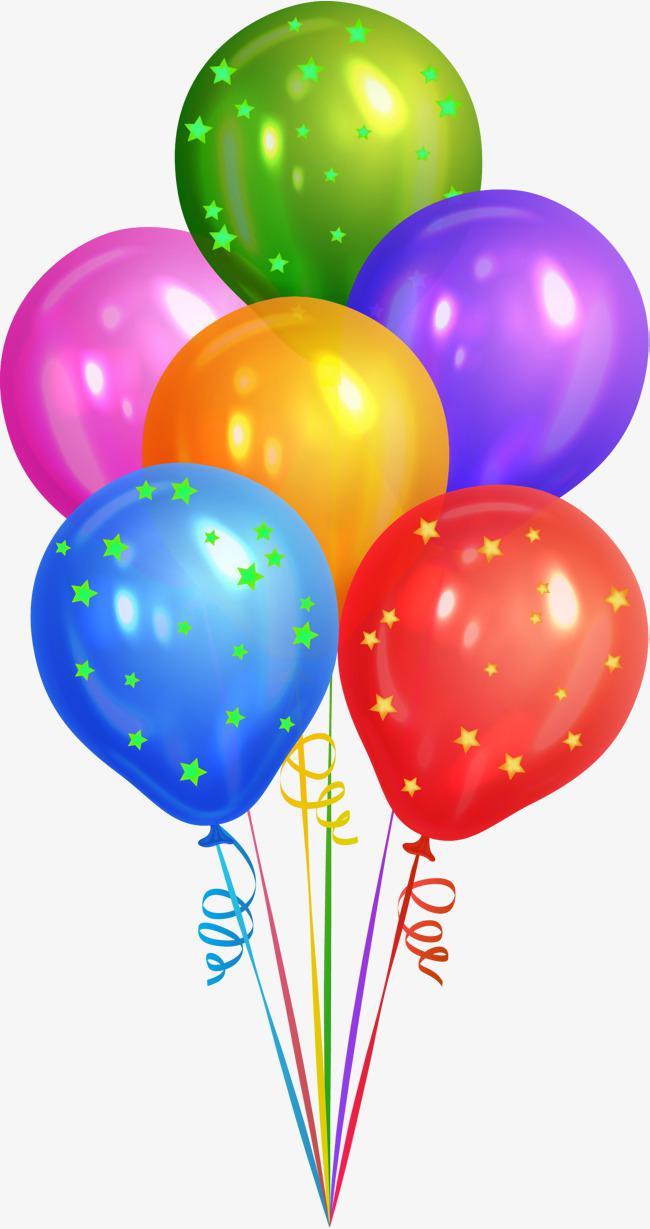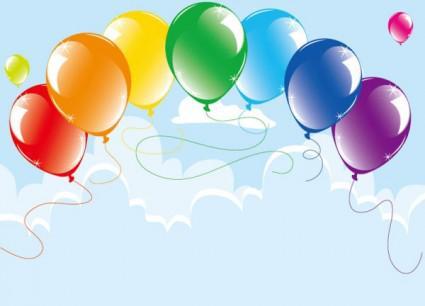The first image is the image on the left, the second image is the image on the right. Analyze the images presented: Is the assertion "One image shows a bunch of balloons with gathered strings and curly ribbons under it, and the other image shows balloons trailing loose strings that don't hang straight." valid? Answer yes or no. Yes. The first image is the image on the left, the second image is the image on the right. Assess this claim about the two images: "in at least one image there are at least fifteen loose balloons on strings.". Correct or not? Answer yes or no. No. 